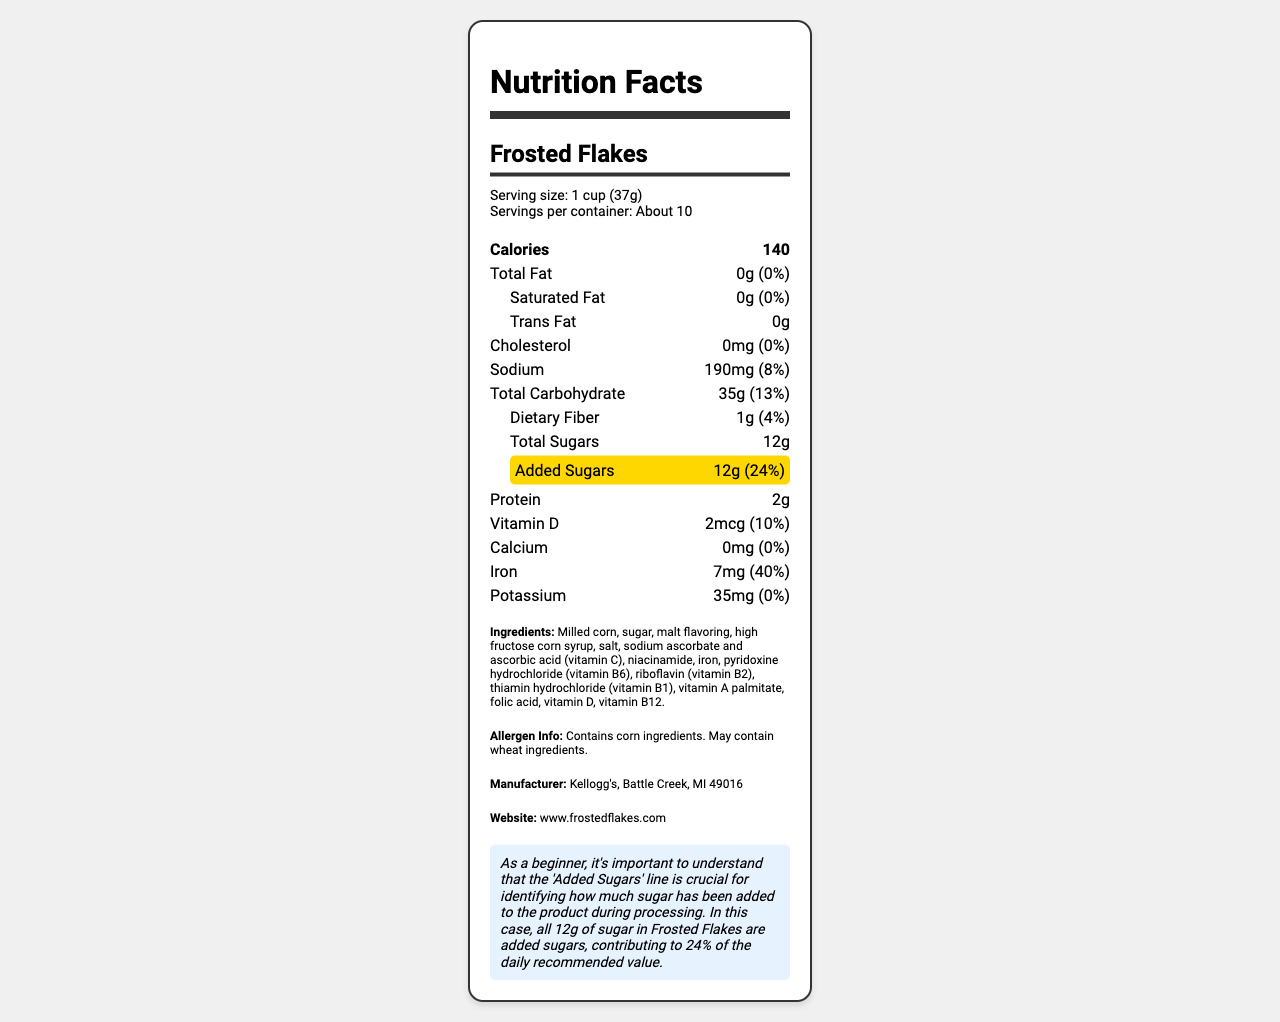what is the serving size? The serving size is clearly mentioned as "1 cup (37g)" in the "Serving size" section of the document.
Answer: 1 cup (37g) how many servings are there per container? The "Servings per container" section states that there are "About 10" servings.
Answer: About 10 how many grams of added sugars are in one serving? The "Added Sugars" section highlights "12g" as the amount of added sugars per serving.
Answer: 12g what percentage of the daily value of added sugars does one serving provide? The "Added Sugars" section indicates that one serving provides "24%" of the daily value.
Answer: 24% how much sodium is in one serving? The "Sodium" section lists "190mg" as the amount of sodium per serving.
Answer: 190mg how many calories are in one serving? The "Calories" section indicates there are "140" calories per serving.
Answer: 140 Does the product contain any dietary fiber? The "Total Carbohydrate" section's indent states "1g" of dietary fiber per serving, confirming it does contain dietary fiber.
Answer: Yes what is the main ingredient in the product? The "Ingredients" section lists "Milled corn" as the first ingredient, indicating it is the main ingredient.
Answer: Milled corn which nutrient provides the highest daily value percentage? A. Vitamin D B. Iron C. Calcium D. Sodium Iron provides "40%" of the daily value per serving, the highest percentage among the listed nutrients.
Answer: B. Iron what is the manufacturer's location? A. New York, NY B. Battle Creek, MI C. Los Angeles, CA D. Dallas, TX The "Manufacturer" section states "Kellogg's, Battle Creek, MI 49016."
Answer: B. Battle Creek, MI Does the product contain any allergens? The "Allergen Info" section indicates the product "Contains corn ingredients. May contain wheat ingredients."
Answer: Yes what are the total grams of carbohydrates in one serving? The "Total Carbohydrate" section lists "35g" as the amount of total carbohydrates per serving.
Answer: 35g How many grams of protein are in each serving? The "Protein" section lists "2g" as the amount of protein per serving.
Answer: 2g Can you deduce how this cereal might impact your diet based on sodium content alone? While the sodium content per serving is provided (190mg), it doesn't give a complete picture of the overall nutritional impact without considering other nutrients and overall diet context.
Answer: No, not enough information Describe the main information presented in this document. The document includes a comprehensive set of information about the Frosted Flakes cereal, focusing on its nutritional content per serving and ingredients, helping consumers make informed dietary choices.
Answer: This document presents the Nutrition Facts for Frosted Flakes cereal, detailing the serving size, servings per container, calories, and nutrient amounts per serving. It specifies the amounts and daily values for fats, cholesterol, sodium, carbohydrates, dietary fiber, sugars (including added sugars), protein, and various vitamins and minerals. It also includes ingredient and allergen information, manufacturer details, and a note emphasizing the importance of added sugars. 